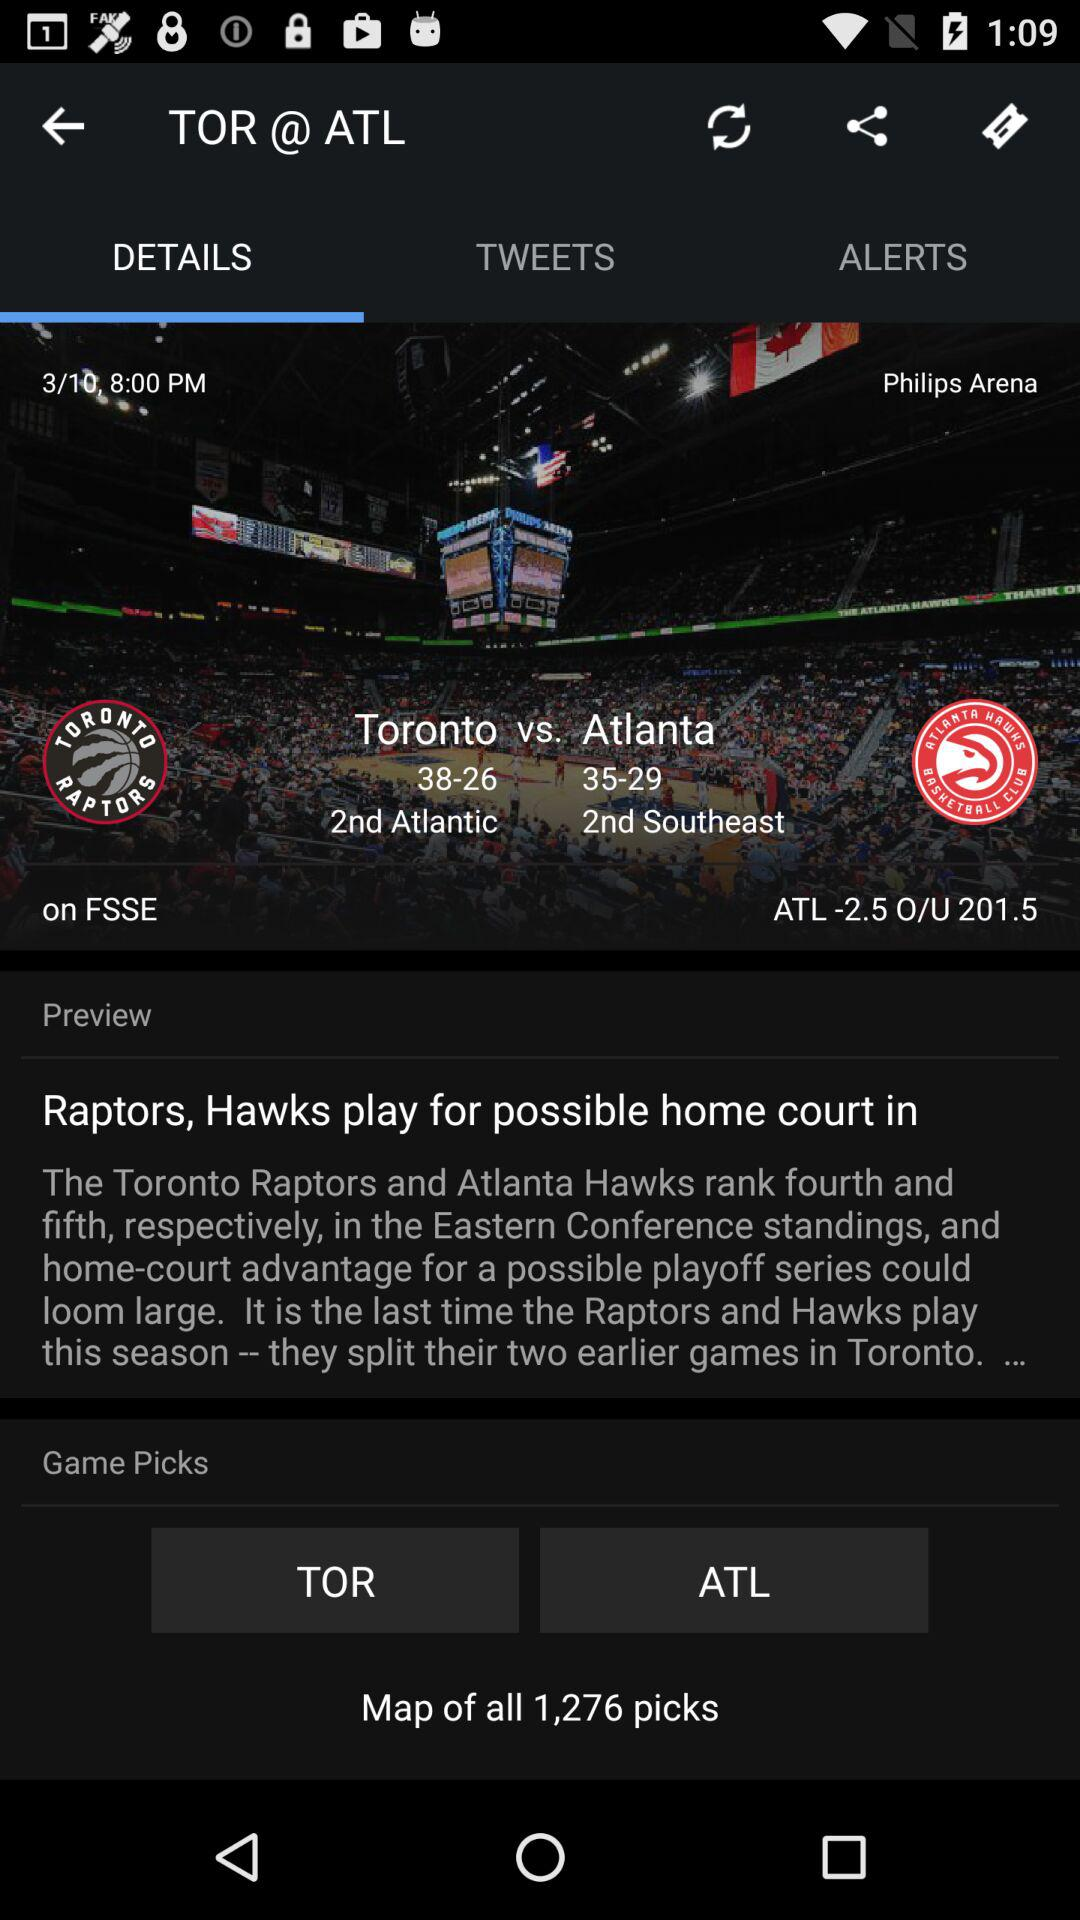How many more wins does Toronto have than Atlanta?
Answer the question using a single word or phrase. 3 